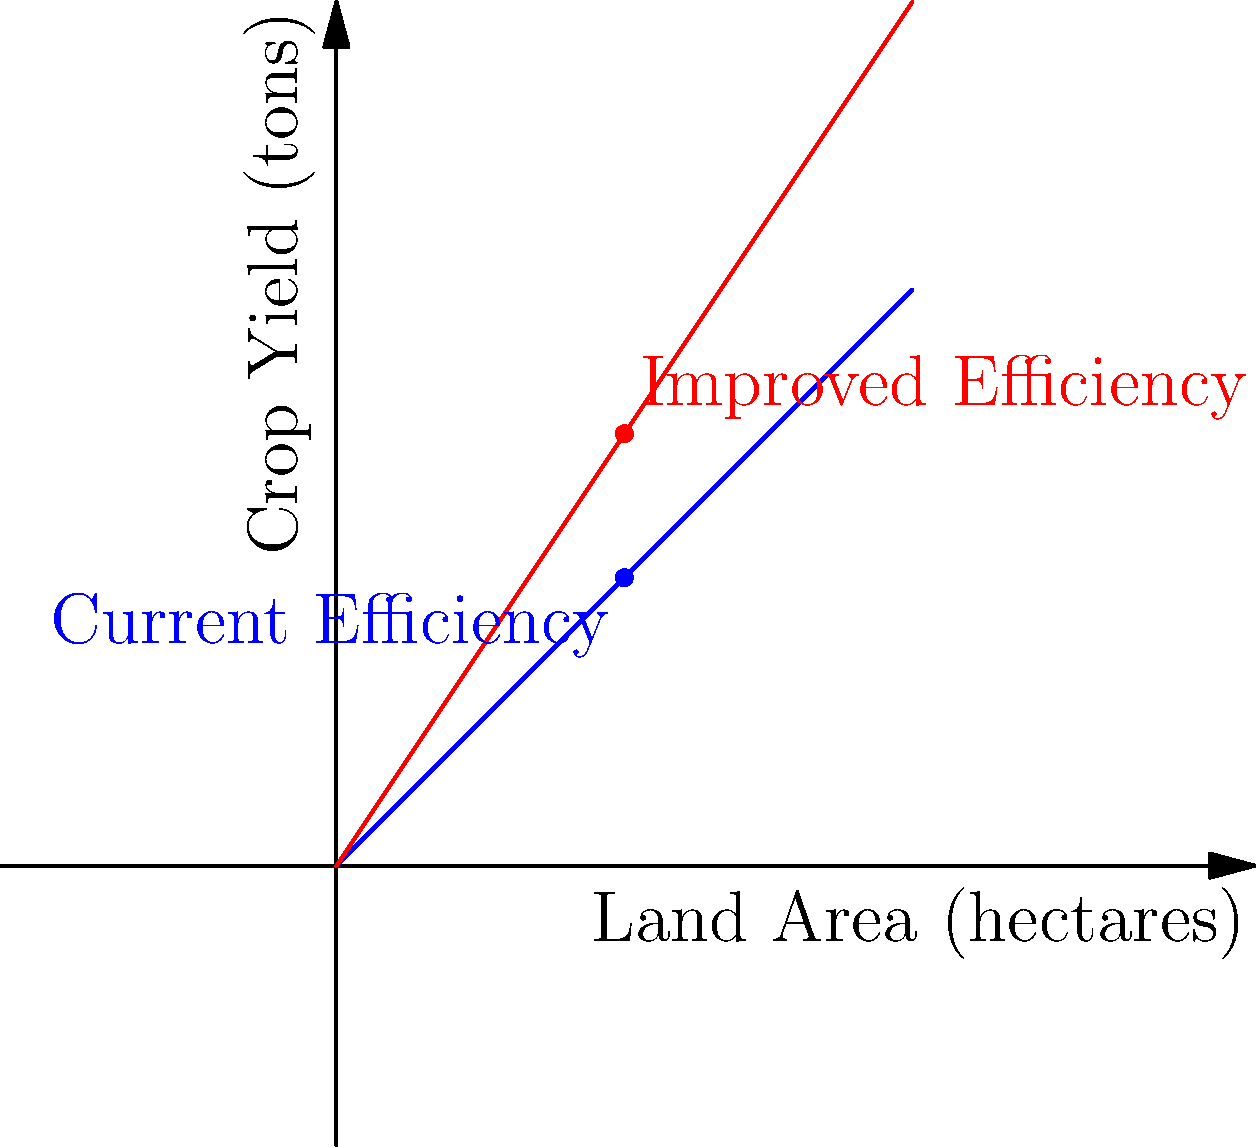A new agricultural policy aims to improve land use efficiency. The graph shows the relationship between land area and crop yield, with the blue line representing current efficiency and the red line representing improved efficiency after policy implementation. If a farm currently produces 50 tons of crops on 50 hectares of land, how many additional tons of crops could be produced on the same land area under the new policy? To solve this problem, we need to follow these steps:

1. Identify the current production point:
   - Current land area: 50 hectares
   - Current crop yield: 50 tons

2. Determine the improved production for the same land area:
   - The red line represents the improved efficiency
   - At 50 hectares (x-axis), the y-value on the red line represents the new crop yield

3. Calculate the difference:
   - Current efficiency point: (50, 50)
   - Improved efficiency point: (50, 75)
   - The y-coordinate difference represents the additional crop yield

4. Quantify the increase:
   $75 \text{ tons} - 50 \text{ tons} = 25 \text{ tons}$

Therefore, under the new policy, an additional 25 tons of crops could be produced on the same 50 hectares of land.
Answer: 25 tons 